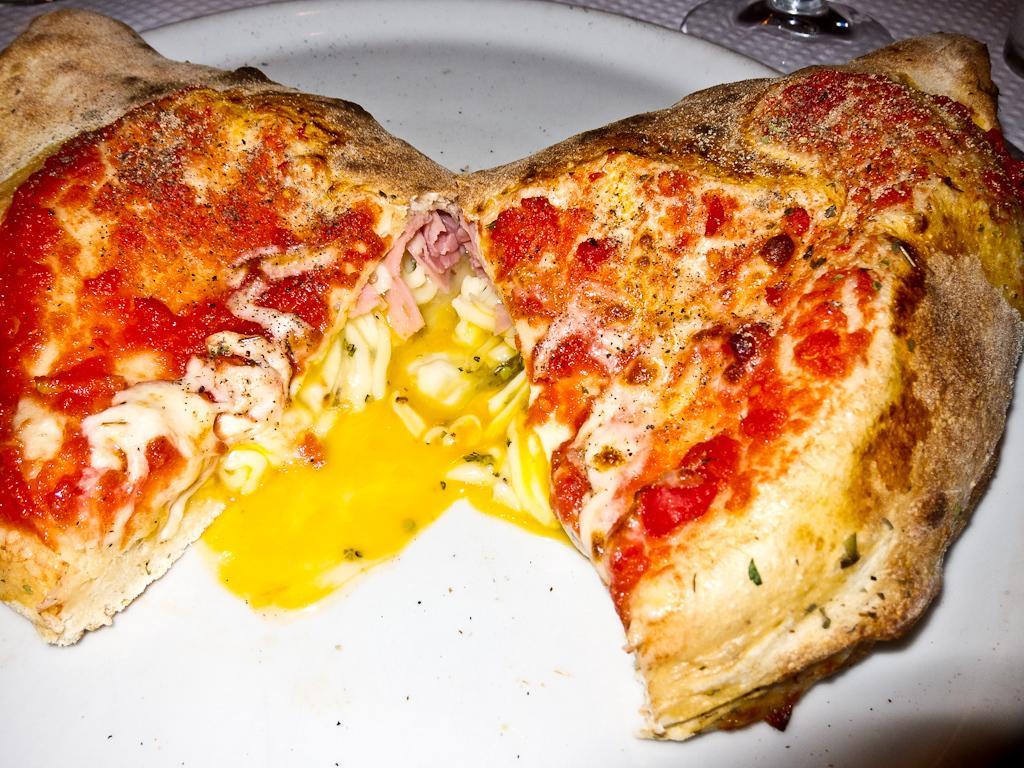How would you summarize this image in a sentence or two? In this image at the bottom there is one plate, in that plate there are some food items and in the background there are glasses. 